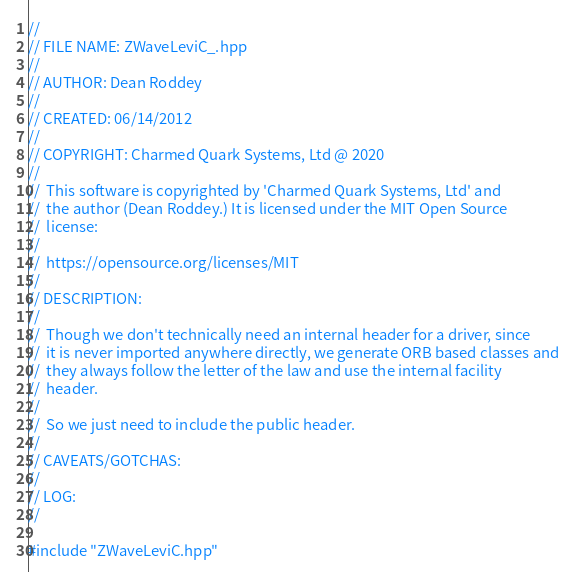<code> <loc_0><loc_0><loc_500><loc_500><_C++_>//
// FILE NAME: ZWaveLeviC_.hpp
//
// AUTHOR: Dean Roddey
//
// CREATED: 06/14/2012
//
// COPYRIGHT: Charmed Quark Systems, Ltd @ 2020
//
//  This software is copyrighted by 'Charmed Quark Systems, Ltd' and 
//  the author (Dean Roddey.) It is licensed under the MIT Open Source 
//  license:
//
//  https://opensource.org/licenses/MIT
//
// DESCRIPTION:
//
//  Though we don't technically need an internal header for a driver, since
//  it is never imported anywhere directly, we generate ORB based classes and
//  they always follow the letter of the law and use the internal facility
//  header.
//
//  So we just need to include the public header.
//
// CAVEATS/GOTCHAS:
//
// LOG:
//

#include "ZWaveLeviC.hpp"

</code> 